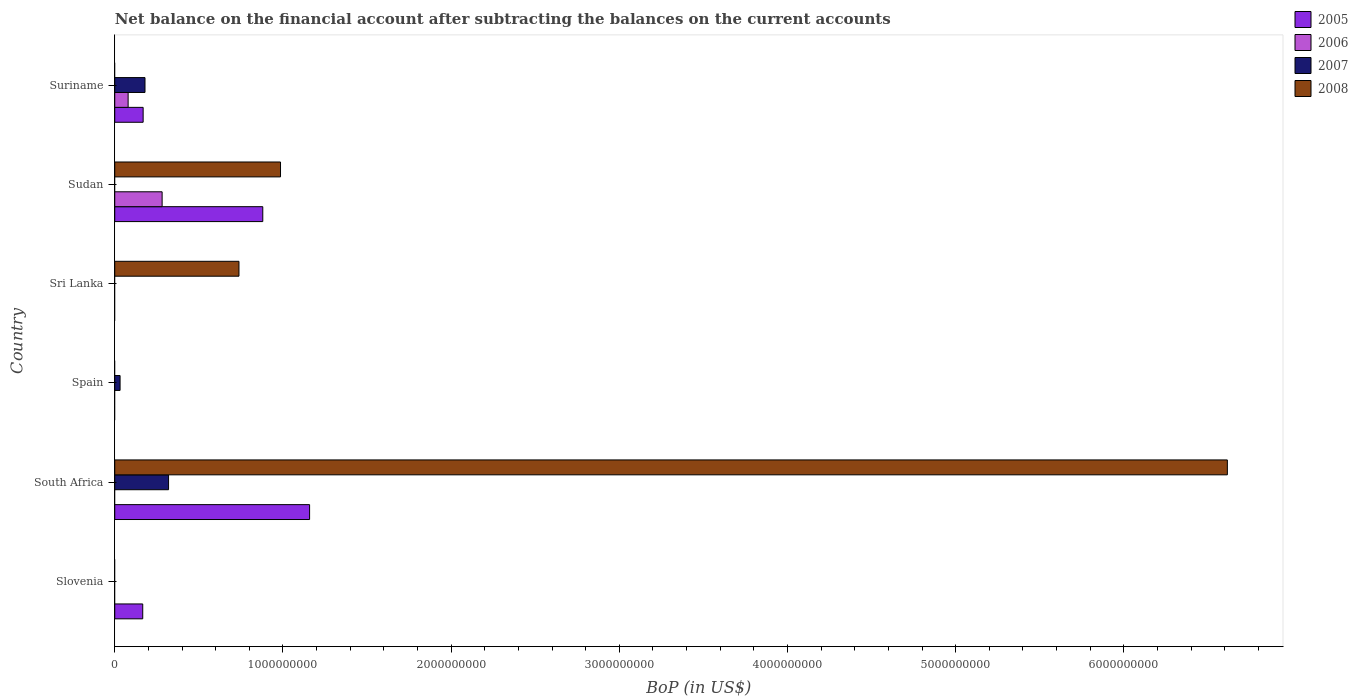How many different coloured bars are there?
Make the answer very short. 4. Are the number of bars on each tick of the Y-axis equal?
Offer a terse response. No. How many bars are there on the 4th tick from the top?
Provide a short and direct response. 1. What is the label of the 6th group of bars from the top?
Give a very brief answer. Slovenia. Across all countries, what is the maximum Balance of Payments in 2005?
Your response must be concise. 1.16e+09. Across all countries, what is the minimum Balance of Payments in 2007?
Ensure brevity in your answer.  0. In which country was the Balance of Payments in 2005 maximum?
Provide a succinct answer. South Africa. What is the total Balance of Payments in 2007 in the graph?
Offer a terse response. 5.31e+08. What is the difference between the Balance of Payments in 2007 in Spain and that in Suriname?
Give a very brief answer. -1.48e+08. What is the difference between the Balance of Payments in 2008 in Suriname and the Balance of Payments in 2005 in Slovenia?
Provide a succinct answer. -1.66e+08. What is the average Balance of Payments in 2006 per country?
Your answer should be very brief. 6.02e+07. What is the difference between the Balance of Payments in 2008 and Balance of Payments in 2005 in Sudan?
Your answer should be compact. 1.05e+08. Is the Balance of Payments in 2005 in South Africa less than that in Sudan?
Provide a succinct answer. No. What is the difference between the highest and the second highest Balance of Payments in 2007?
Your response must be concise. 1.40e+08. What is the difference between the highest and the lowest Balance of Payments in 2006?
Ensure brevity in your answer.  2.82e+08. Is the sum of the Balance of Payments in 2005 in Slovenia and South Africa greater than the maximum Balance of Payments in 2007 across all countries?
Your answer should be very brief. Yes. Are all the bars in the graph horizontal?
Your answer should be compact. Yes. How many countries are there in the graph?
Give a very brief answer. 6. What is the difference between two consecutive major ticks on the X-axis?
Offer a terse response. 1.00e+09. Are the values on the major ticks of X-axis written in scientific E-notation?
Your answer should be very brief. No. Does the graph contain any zero values?
Ensure brevity in your answer.  Yes. How many legend labels are there?
Your answer should be very brief. 4. How are the legend labels stacked?
Offer a very short reply. Vertical. What is the title of the graph?
Make the answer very short. Net balance on the financial account after subtracting the balances on the current accounts. What is the label or title of the X-axis?
Your answer should be very brief. BoP (in US$). What is the BoP (in US$) in 2005 in Slovenia?
Keep it short and to the point. 1.66e+08. What is the BoP (in US$) in 2006 in Slovenia?
Ensure brevity in your answer.  0. What is the BoP (in US$) in 2007 in Slovenia?
Ensure brevity in your answer.  0. What is the BoP (in US$) in 2008 in Slovenia?
Your answer should be compact. 0. What is the BoP (in US$) in 2005 in South Africa?
Ensure brevity in your answer.  1.16e+09. What is the BoP (in US$) in 2007 in South Africa?
Ensure brevity in your answer.  3.20e+08. What is the BoP (in US$) in 2008 in South Africa?
Your response must be concise. 6.62e+09. What is the BoP (in US$) in 2006 in Spain?
Your answer should be very brief. 0. What is the BoP (in US$) in 2007 in Spain?
Offer a terse response. 3.16e+07. What is the BoP (in US$) in 2005 in Sri Lanka?
Ensure brevity in your answer.  0. What is the BoP (in US$) in 2007 in Sri Lanka?
Ensure brevity in your answer.  0. What is the BoP (in US$) of 2008 in Sri Lanka?
Keep it short and to the point. 7.39e+08. What is the BoP (in US$) of 2005 in Sudan?
Your answer should be very brief. 8.80e+08. What is the BoP (in US$) of 2006 in Sudan?
Provide a short and direct response. 2.82e+08. What is the BoP (in US$) in 2008 in Sudan?
Provide a short and direct response. 9.86e+08. What is the BoP (in US$) of 2005 in Suriname?
Keep it short and to the point. 1.69e+08. What is the BoP (in US$) of 2006 in Suriname?
Provide a succinct answer. 7.95e+07. What is the BoP (in US$) in 2007 in Suriname?
Offer a very short reply. 1.80e+08. What is the BoP (in US$) in 2008 in Suriname?
Provide a short and direct response. 0. Across all countries, what is the maximum BoP (in US$) in 2005?
Offer a terse response. 1.16e+09. Across all countries, what is the maximum BoP (in US$) of 2006?
Your answer should be very brief. 2.82e+08. Across all countries, what is the maximum BoP (in US$) in 2007?
Your response must be concise. 3.20e+08. Across all countries, what is the maximum BoP (in US$) in 2008?
Provide a succinct answer. 6.62e+09. Across all countries, what is the minimum BoP (in US$) in 2005?
Provide a succinct answer. 0. Across all countries, what is the minimum BoP (in US$) of 2006?
Ensure brevity in your answer.  0. Across all countries, what is the minimum BoP (in US$) of 2007?
Ensure brevity in your answer.  0. Across all countries, what is the minimum BoP (in US$) in 2008?
Give a very brief answer. 0. What is the total BoP (in US$) of 2005 in the graph?
Make the answer very short. 2.37e+09. What is the total BoP (in US$) of 2006 in the graph?
Provide a short and direct response. 3.61e+08. What is the total BoP (in US$) in 2007 in the graph?
Your response must be concise. 5.31e+08. What is the total BoP (in US$) of 2008 in the graph?
Your response must be concise. 8.34e+09. What is the difference between the BoP (in US$) in 2005 in Slovenia and that in South Africa?
Offer a very short reply. -9.92e+08. What is the difference between the BoP (in US$) in 2005 in Slovenia and that in Sudan?
Your answer should be compact. -7.14e+08. What is the difference between the BoP (in US$) of 2005 in Slovenia and that in Suriname?
Keep it short and to the point. -2.41e+06. What is the difference between the BoP (in US$) of 2007 in South Africa and that in Spain?
Keep it short and to the point. 2.88e+08. What is the difference between the BoP (in US$) of 2008 in South Africa and that in Sri Lanka?
Provide a short and direct response. 5.88e+09. What is the difference between the BoP (in US$) of 2005 in South Africa and that in Sudan?
Give a very brief answer. 2.78e+08. What is the difference between the BoP (in US$) of 2008 in South Africa and that in Sudan?
Provide a short and direct response. 5.63e+09. What is the difference between the BoP (in US$) in 2005 in South Africa and that in Suriname?
Make the answer very short. 9.90e+08. What is the difference between the BoP (in US$) in 2007 in South Africa and that in Suriname?
Provide a short and direct response. 1.40e+08. What is the difference between the BoP (in US$) of 2007 in Spain and that in Suriname?
Give a very brief answer. -1.48e+08. What is the difference between the BoP (in US$) of 2008 in Sri Lanka and that in Sudan?
Give a very brief answer. -2.47e+08. What is the difference between the BoP (in US$) in 2005 in Sudan and that in Suriname?
Make the answer very short. 7.11e+08. What is the difference between the BoP (in US$) in 2006 in Sudan and that in Suriname?
Offer a very short reply. 2.02e+08. What is the difference between the BoP (in US$) of 2005 in Slovenia and the BoP (in US$) of 2007 in South Africa?
Keep it short and to the point. -1.54e+08. What is the difference between the BoP (in US$) of 2005 in Slovenia and the BoP (in US$) of 2008 in South Africa?
Provide a short and direct response. -6.45e+09. What is the difference between the BoP (in US$) in 2005 in Slovenia and the BoP (in US$) in 2007 in Spain?
Ensure brevity in your answer.  1.35e+08. What is the difference between the BoP (in US$) of 2005 in Slovenia and the BoP (in US$) of 2008 in Sri Lanka?
Make the answer very short. -5.72e+08. What is the difference between the BoP (in US$) of 2005 in Slovenia and the BoP (in US$) of 2006 in Sudan?
Provide a succinct answer. -1.15e+08. What is the difference between the BoP (in US$) of 2005 in Slovenia and the BoP (in US$) of 2008 in Sudan?
Make the answer very short. -8.19e+08. What is the difference between the BoP (in US$) of 2005 in Slovenia and the BoP (in US$) of 2006 in Suriname?
Provide a short and direct response. 8.69e+07. What is the difference between the BoP (in US$) of 2005 in Slovenia and the BoP (in US$) of 2007 in Suriname?
Ensure brevity in your answer.  -1.34e+07. What is the difference between the BoP (in US$) in 2005 in South Africa and the BoP (in US$) in 2007 in Spain?
Provide a succinct answer. 1.13e+09. What is the difference between the BoP (in US$) in 2005 in South Africa and the BoP (in US$) in 2008 in Sri Lanka?
Provide a short and direct response. 4.20e+08. What is the difference between the BoP (in US$) of 2007 in South Africa and the BoP (in US$) of 2008 in Sri Lanka?
Offer a terse response. -4.19e+08. What is the difference between the BoP (in US$) in 2005 in South Africa and the BoP (in US$) in 2006 in Sudan?
Your answer should be compact. 8.77e+08. What is the difference between the BoP (in US$) in 2005 in South Africa and the BoP (in US$) in 2008 in Sudan?
Your response must be concise. 1.73e+08. What is the difference between the BoP (in US$) in 2007 in South Africa and the BoP (in US$) in 2008 in Sudan?
Your answer should be compact. -6.66e+08. What is the difference between the BoP (in US$) in 2005 in South Africa and the BoP (in US$) in 2006 in Suriname?
Your answer should be very brief. 1.08e+09. What is the difference between the BoP (in US$) in 2005 in South Africa and the BoP (in US$) in 2007 in Suriname?
Offer a very short reply. 9.79e+08. What is the difference between the BoP (in US$) in 2007 in Spain and the BoP (in US$) in 2008 in Sri Lanka?
Offer a terse response. -7.07e+08. What is the difference between the BoP (in US$) of 2007 in Spain and the BoP (in US$) of 2008 in Sudan?
Offer a very short reply. -9.54e+08. What is the difference between the BoP (in US$) of 2005 in Sudan and the BoP (in US$) of 2006 in Suriname?
Provide a succinct answer. 8.01e+08. What is the difference between the BoP (in US$) of 2005 in Sudan and the BoP (in US$) of 2007 in Suriname?
Ensure brevity in your answer.  7.00e+08. What is the difference between the BoP (in US$) in 2006 in Sudan and the BoP (in US$) in 2007 in Suriname?
Offer a terse response. 1.02e+08. What is the average BoP (in US$) in 2005 per country?
Ensure brevity in your answer.  3.96e+08. What is the average BoP (in US$) in 2006 per country?
Your response must be concise. 6.02e+07. What is the average BoP (in US$) of 2007 per country?
Provide a short and direct response. 8.86e+07. What is the average BoP (in US$) in 2008 per country?
Keep it short and to the point. 1.39e+09. What is the difference between the BoP (in US$) of 2005 and BoP (in US$) of 2007 in South Africa?
Provide a short and direct response. 8.39e+08. What is the difference between the BoP (in US$) in 2005 and BoP (in US$) in 2008 in South Africa?
Keep it short and to the point. -5.46e+09. What is the difference between the BoP (in US$) in 2007 and BoP (in US$) in 2008 in South Africa?
Your answer should be compact. -6.30e+09. What is the difference between the BoP (in US$) of 2005 and BoP (in US$) of 2006 in Sudan?
Your response must be concise. 5.98e+08. What is the difference between the BoP (in US$) in 2005 and BoP (in US$) in 2008 in Sudan?
Make the answer very short. -1.05e+08. What is the difference between the BoP (in US$) of 2006 and BoP (in US$) of 2008 in Sudan?
Offer a terse response. -7.04e+08. What is the difference between the BoP (in US$) of 2005 and BoP (in US$) of 2006 in Suriname?
Keep it short and to the point. 8.93e+07. What is the difference between the BoP (in US$) of 2005 and BoP (in US$) of 2007 in Suriname?
Your answer should be very brief. -1.10e+07. What is the difference between the BoP (in US$) of 2006 and BoP (in US$) of 2007 in Suriname?
Provide a succinct answer. -1.00e+08. What is the ratio of the BoP (in US$) of 2005 in Slovenia to that in South Africa?
Offer a very short reply. 0.14. What is the ratio of the BoP (in US$) in 2005 in Slovenia to that in Sudan?
Your answer should be compact. 0.19. What is the ratio of the BoP (in US$) of 2005 in Slovenia to that in Suriname?
Offer a very short reply. 0.99. What is the ratio of the BoP (in US$) of 2007 in South Africa to that in Spain?
Ensure brevity in your answer.  10.11. What is the ratio of the BoP (in US$) of 2008 in South Africa to that in Sri Lanka?
Ensure brevity in your answer.  8.96. What is the ratio of the BoP (in US$) of 2005 in South Africa to that in Sudan?
Make the answer very short. 1.32. What is the ratio of the BoP (in US$) in 2008 in South Africa to that in Sudan?
Provide a succinct answer. 6.71. What is the ratio of the BoP (in US$) in 2005 in South Africa to that in Suriname?
Offer a very short reply. 6.86. What is the ratio of the BoP (in US$) of 2007 in South Africa to that in Suriname?
Provide a succinct answer. 1.78. What is the ratio of the BoP (in US$) in 2007 in Spain to that in Suriname?
Provide a short and direct response. 0.18. What is the ratio of the BoP (in US$) of 2008 in Sri Lanka to that in Sudan?
Your response must be concise. 0.75. What is the ratio of the BoP (in US$) of 2005 in Sudan to that in Suriname?
Offer a terse response. 5.21. What is the ratio of the BoP (in US$) of 2006 in Sudan to that in Suriname?
Provide a succinct answer. 3.54. What is the difference between the highest and the second highest BoP (in US$) of 2005?
Your answer should be compact. 2.78e+08. What is the difference between the highest and the second highest BoP (in US$) of 2007?
Your response must be concise. 1.40e+08. What is the difference between the highest and the second highest BoP (in US$) of 2008?
Your answer should be very brief. 5.63e+09. What is the difference between the highest and the lowest BoP (in US$) in 2005?
Keep it short and to the point. 1.16e+09. What is the difference between the highest and the lowest BoP (in US$) of 2006?
Provide a short and direct response. 2.82e+08. What is the difference between the highest and the lowest BoP (in US$) of 2007?
Ensure brevity in your answer.  3.20e+08. What is the difference between the highest and the lowest BoP (in US$) in 2008?
Your answer should be compact. 6.62e+09. 